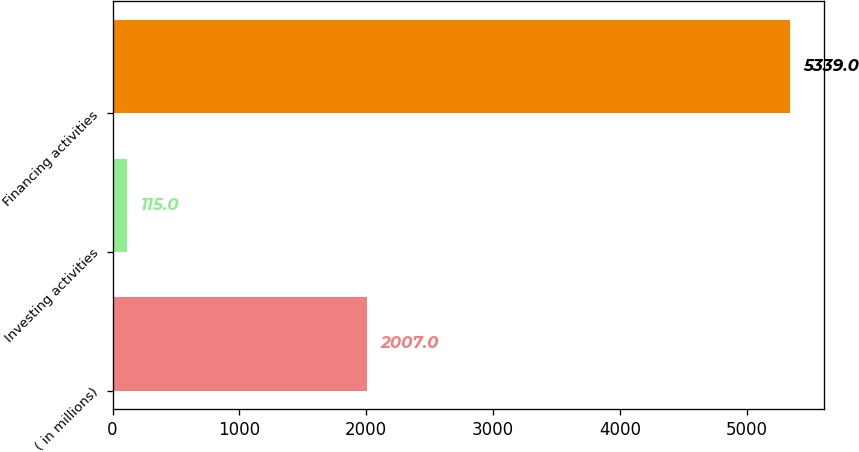Convert chart. <chart><loc_0><loc_0><loc_500><loc_500><bar_chart><fcel>( in millions)<fcel>Investing activities<fcel>Financing activities<nl><fcel>2007<fcel>115<fcel>5339<nl></chart> 